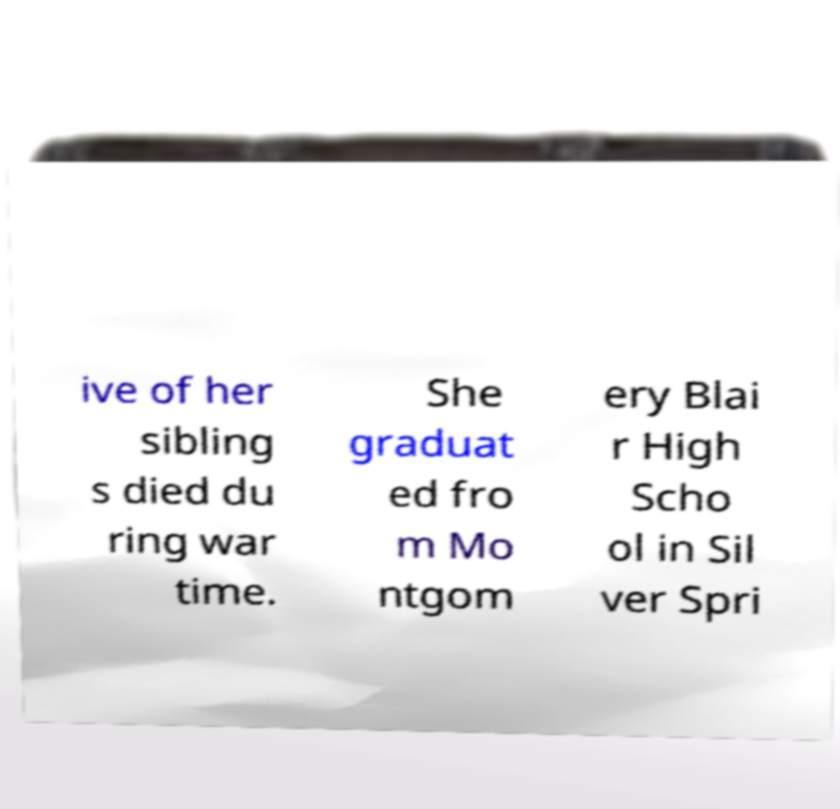Please identify and transcribe the text found in this image. ive of her sibling s died du ring war time. She graduat ed fro m Mo ntgom ery Blai r High Scho ol in Sil ver Spri 